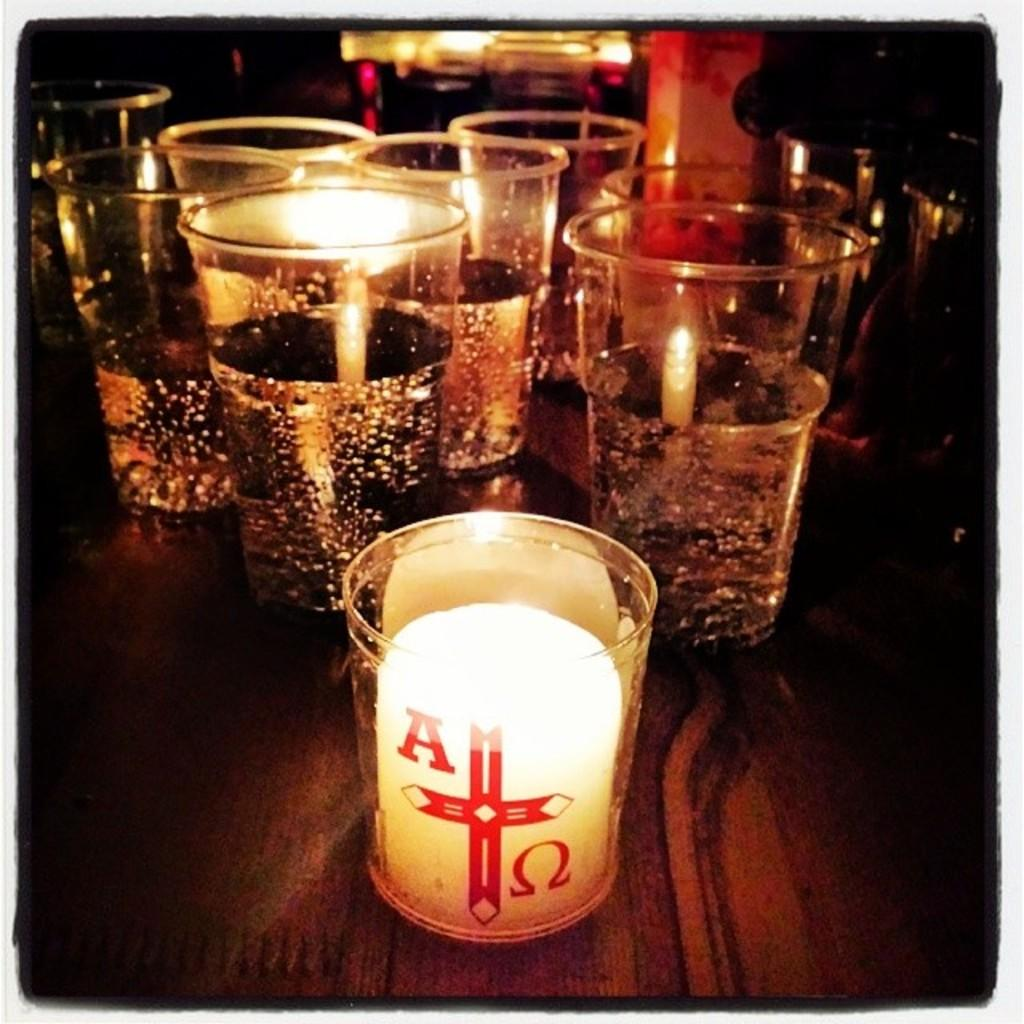<image>
Render a clear and concise summary of the photo. A white candle holder has a ed cross with an A on the left side. 